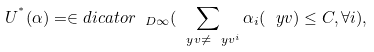<formula> <loc_0><loc_0><loc_500><loc_500>U ^ { ^ { * } } ( \alpha ) = \in d i c a t o r _ { \ D \infty } ( \sum _ { \ y v \neq \ y v ^ { i } } \alpha _ { i } ( \ y v ) \leq C , \forall i ) ,</formula> 